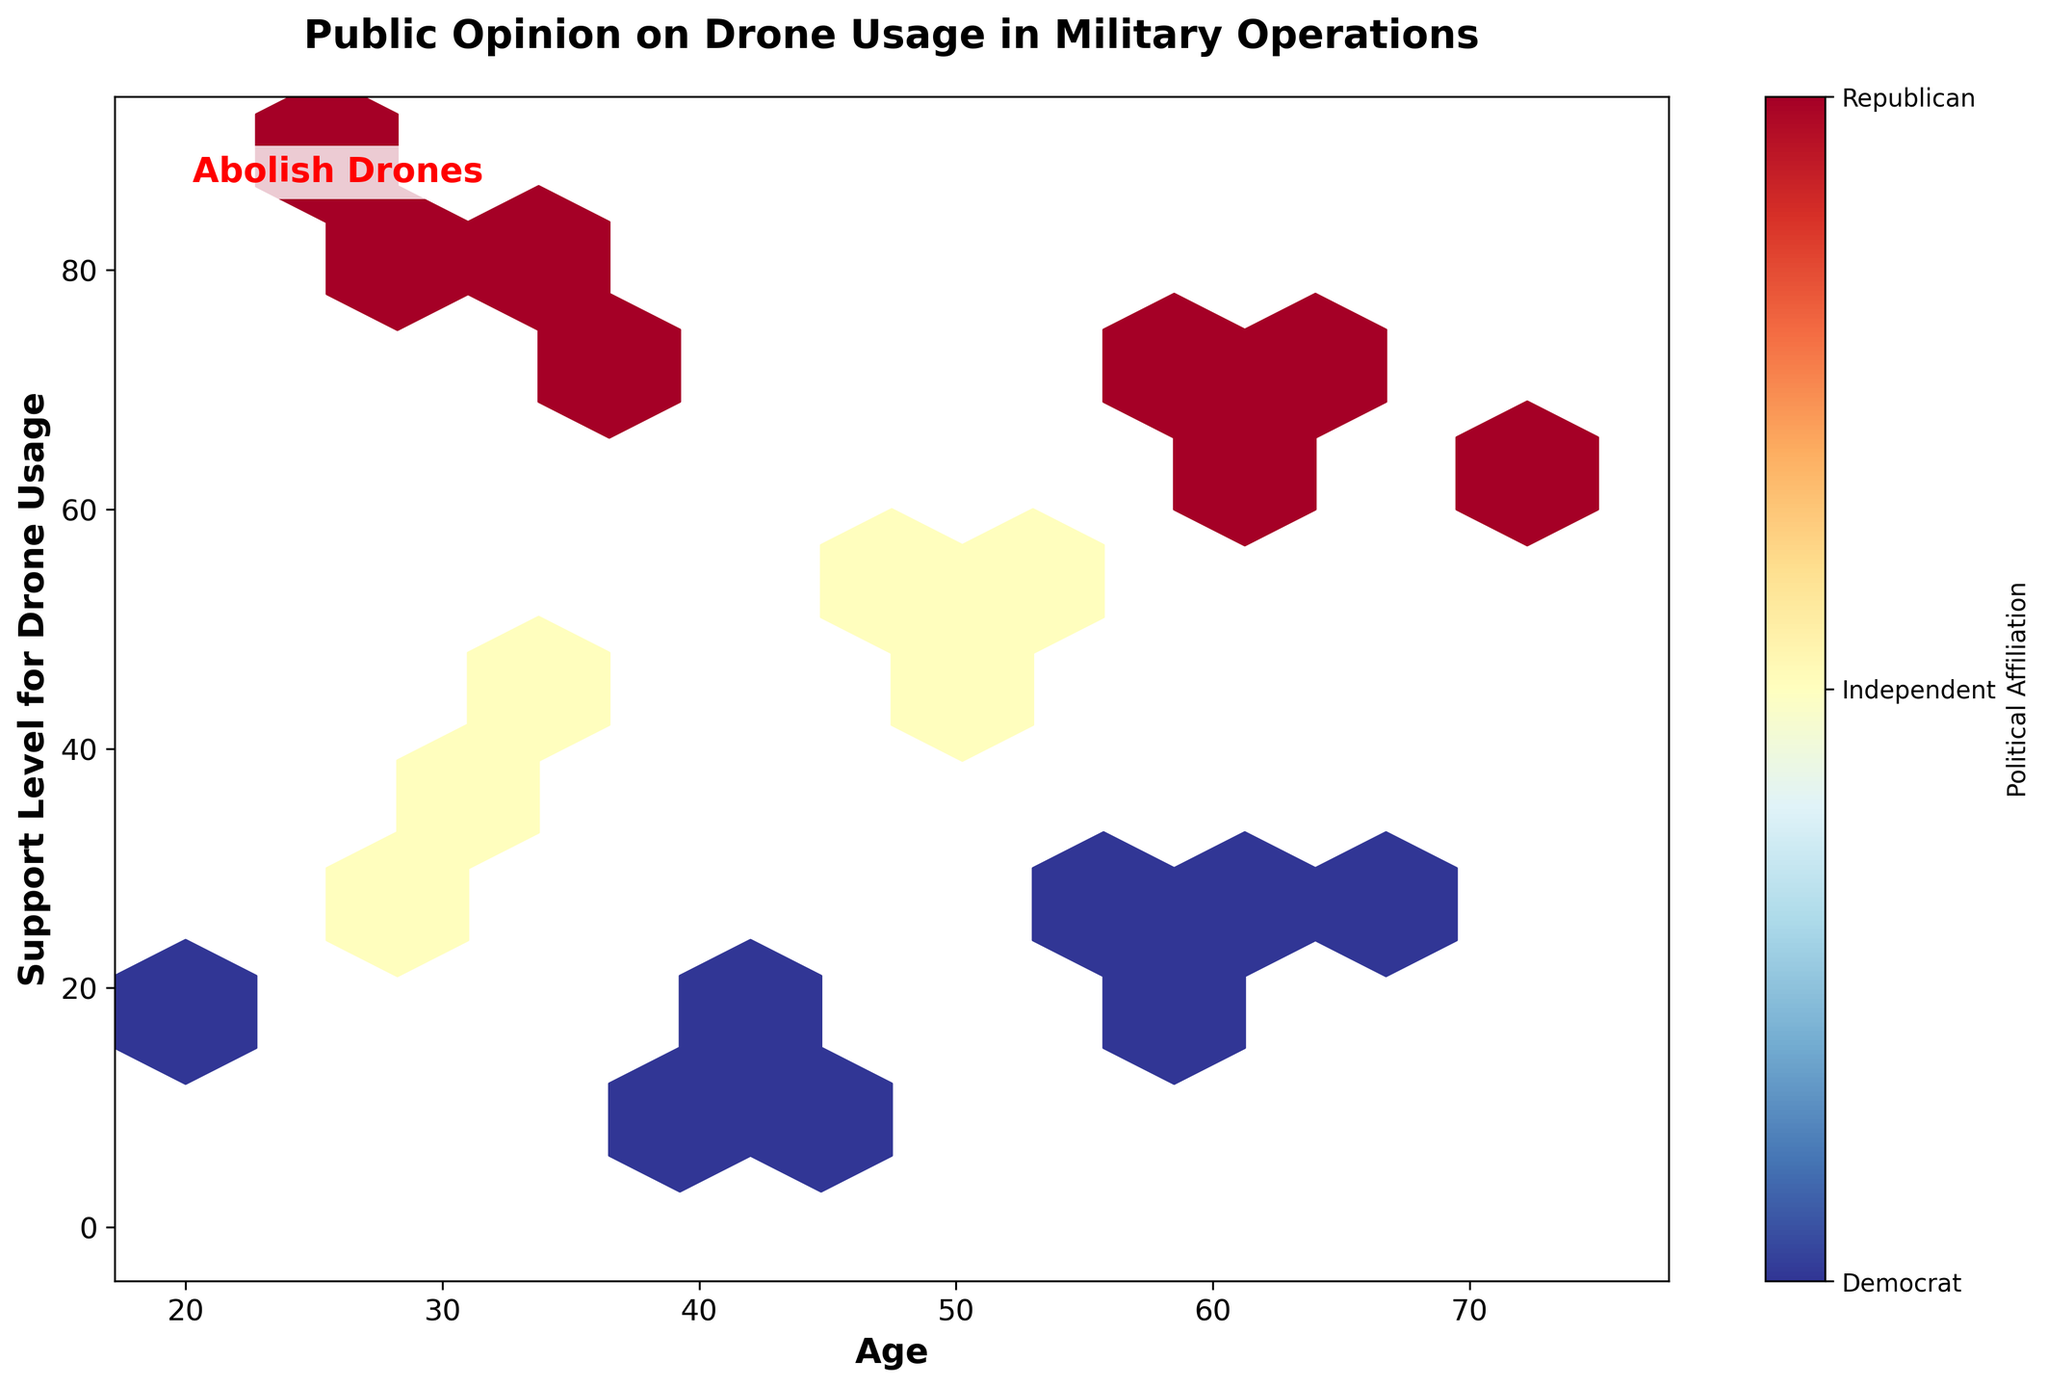What is the title of the plot? The title of the plot is the text that appears at the top, summarizing what the plot represents.
Answer: Public Opinion on Drone Usage in Military Operations What do the x and y axes represent? The axes labels show the variables plotted. The x axis represents age, and the y axis represents Support Level for Drone Usage.
Answer: Age on x axis, Support Level for Drone Usage on y axis How is political affiliation represented in the plot? Political affiliation is represented by the color of the hexagons. The color bar shows values from Democrat (0), Independent (0.5), to Republican (1).
Answer: By color: Democrat (0), Independent (0.5), Republican (1) Where do most Republican supporters fall in terms of support level? To determine where most Republican supporters fall, look for areas with hexagons that are reddish, particularly assessing the support level along the y-axis.
Answer: High Support Level (60-85) Which age group has the highest density of Democratic supporters? To find this, look for dense clusters of hexagons colored towards the blue end of the spectrum along the x-axis.
Answer: Older age groups (around 55-70 years old) What's the typical range of support levels for Independent supporters? Look for hexagons shaded with colors representative of Independents (approximately middle of color scale), and examine the spread along the y axis.
Answer: 35-55 Compare the support levels of Democrats and Republicans in the 30-40 age range. Look at the color gradients of hexagons in the 30-40 age range; redder for Republicans, bluer for Democrats, and their positions along the support level (y axis).
Answer: Republicans: Higher (75-80), Democrats: Lower (10-20) What is the correlation between age and support level for drone usage among Republicans? Assess the general trend of reddish hexagons as age (x-axis) increases to see if support levels (y-axis) rise or fall.
Answer: Positive correlation Is there any visible group that overwhelmingly supports drone usage? Identify any section of the plot with a high concentration of densely colored hexagons regardless of color, especially towards the higher y-axis values.
Answer: Republicans (70-85 support level) What do the text annotations "Abolish Drones" on the figure indicate? The text "Abolish Drones", highlighted in red, suggests the message of the plot creator rather than data insights, likely indicating their stance against drone usage.
Answer: Advocate's anti-drone message 